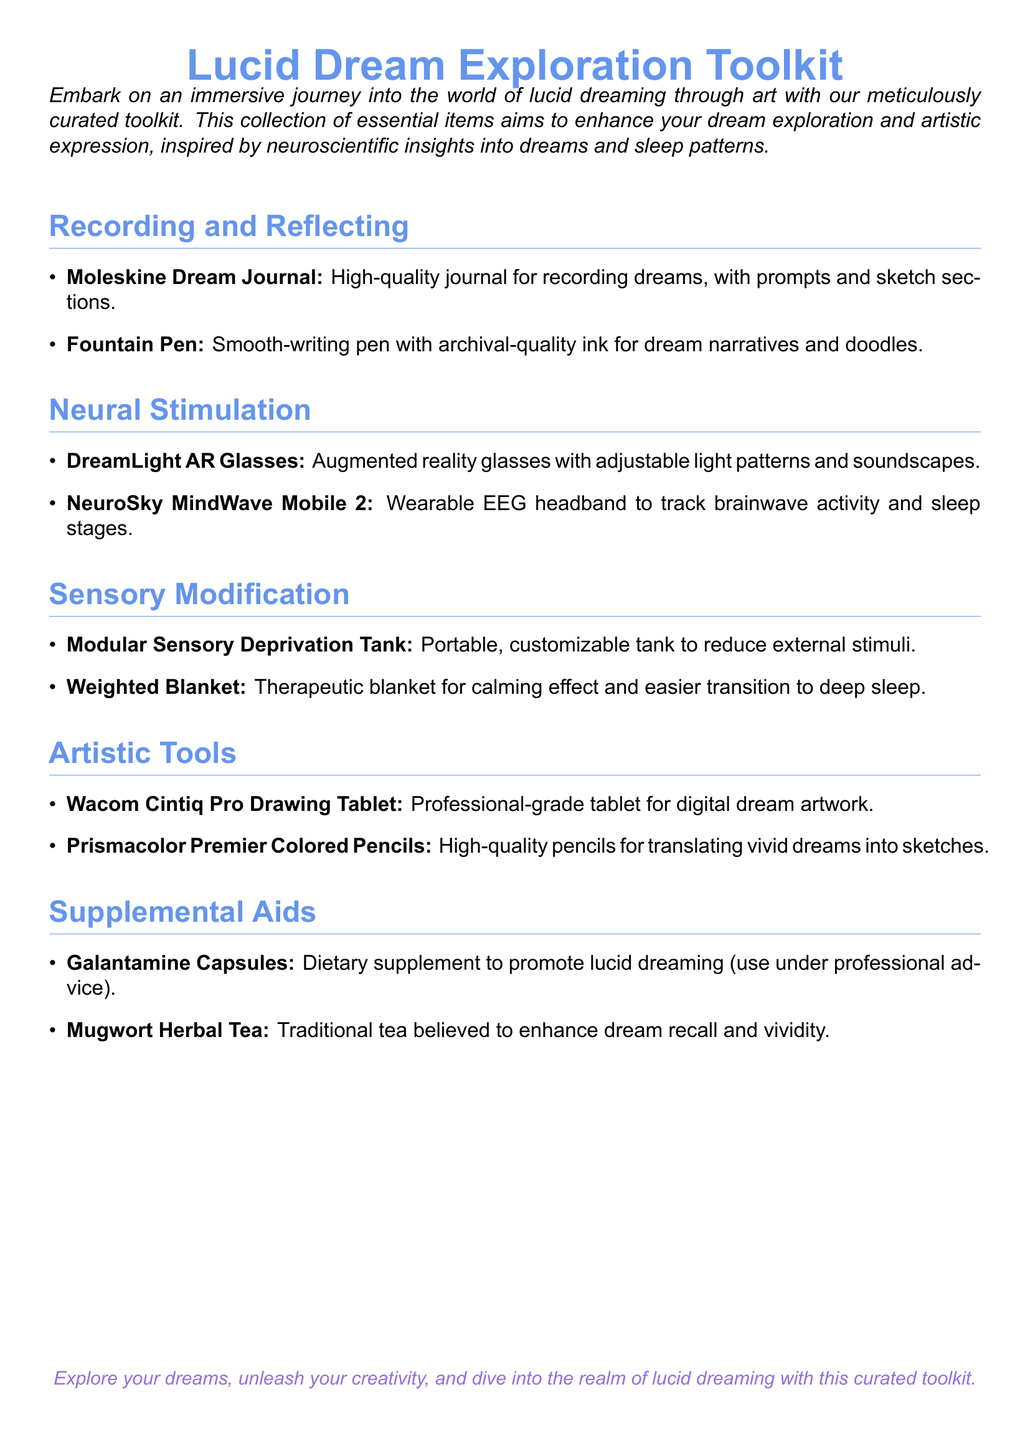What is the purpose of the toolkit? The purpose of the toolkit is to enhance dream exploration and artistic expression, inspired by neuroscientific insights into dreams and sleep patterns.
Answer: Enhance dream exploration and artistic expression How many items are listed under "Recording and Reflecting"? There are two items listed under "Recording and Reflecting": Moleskine Dream Journal and Fountain Pen.
Answer: 2 What are DreamLight AR Glasses designed to provide? DreamLight AR Glasses are designed to provide adjustable light patterns and soundscapes.
Answer: Adjustable light patterns and soundscapes Which dietary supplement is mentioned in the toolkit? The dietary supplement mentioned in the toolkit is Galantamine Capsules.
Answer: Galantamine Capsules What type of blanket is suggested for a calming effect? The suggested blanket for a calming effect is a Weighted Blanket.
Answer: Weighted Blanket What artistic tool is recommended for digital dream artwork? The recommended artistic tool for digital dream artwork is the Wacom Cintiq Pro Drawing Tablet.
Answer: Wacom Cintiq Pro Drawing Tablet How is the Modular Sensory Deprivation Tank described? The Modular Sensory Deprivation Tank is described as portable and customizable to reduce external stimuli.
Answer: Portable, customizable What color blue is used in the document's title? The color blue used in the document's title is Dream Blue.
Answer: Dream Blue How can Mugwort Herbal Tea affect dreams? Mugwort Herbal Tea is believed to enhance dream recall and vividity.
Answer: Enhance dream recall and vividity 